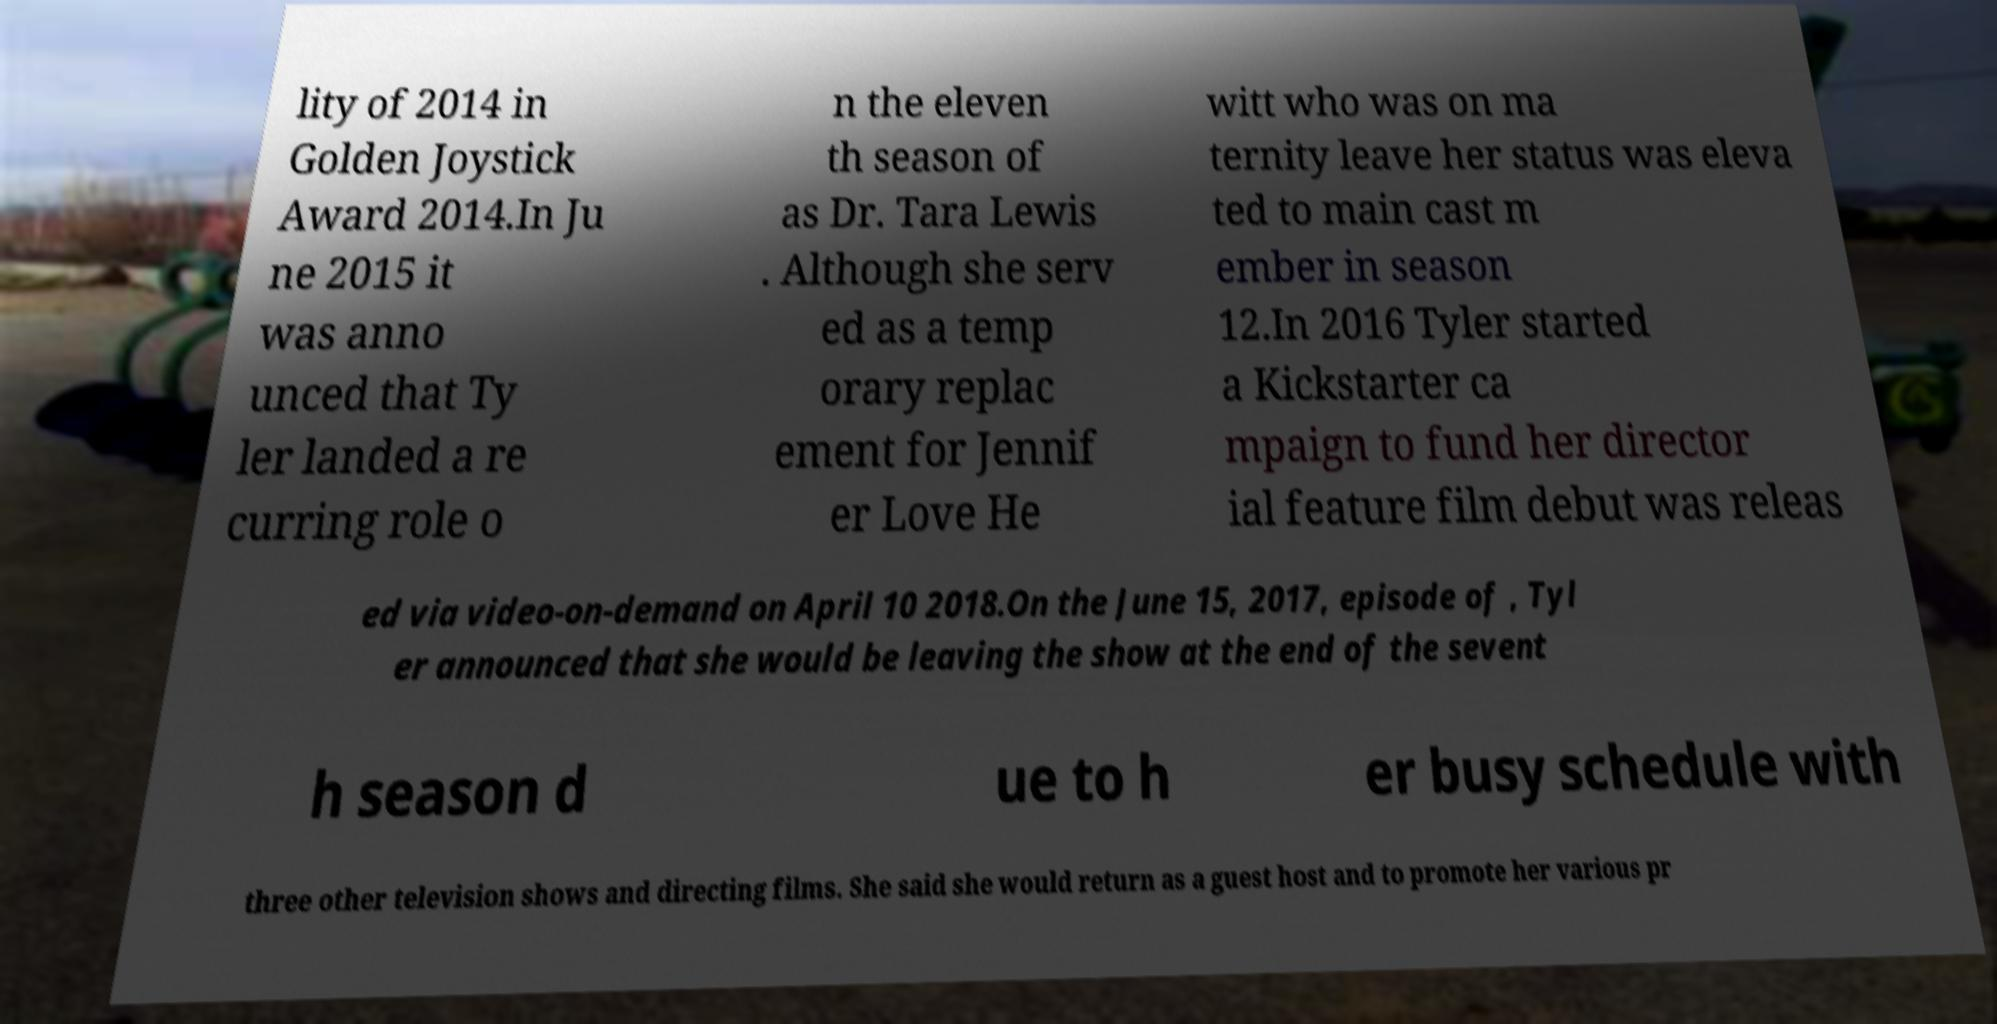Could you extract and type out the text from this image? lity of 2014 in Golden Joystick Award 2014.In Ju ne 2015 it was anno unced that Ty ler landed a re curring role o n the eleven th season of as Dr. Tara Lewis . Although she serv ed as a temp orary replac ement for Jennif er Love He witt who was on ma ternity leave her status was eleva ted to main cast m ember in season 12.In 2016 Tyler started a Kickstarter ca mpaign to fund her director ial feature film debut was releas ed via video-on-demand on April 10 2018.On the June 15, 2017, episode of , Tyl er announced that she would be leaving the show at the end of the sevent h season d ue to h er busy schedule with three other television shows and directing films. She said she would return as a guest host and to promote her various pr 